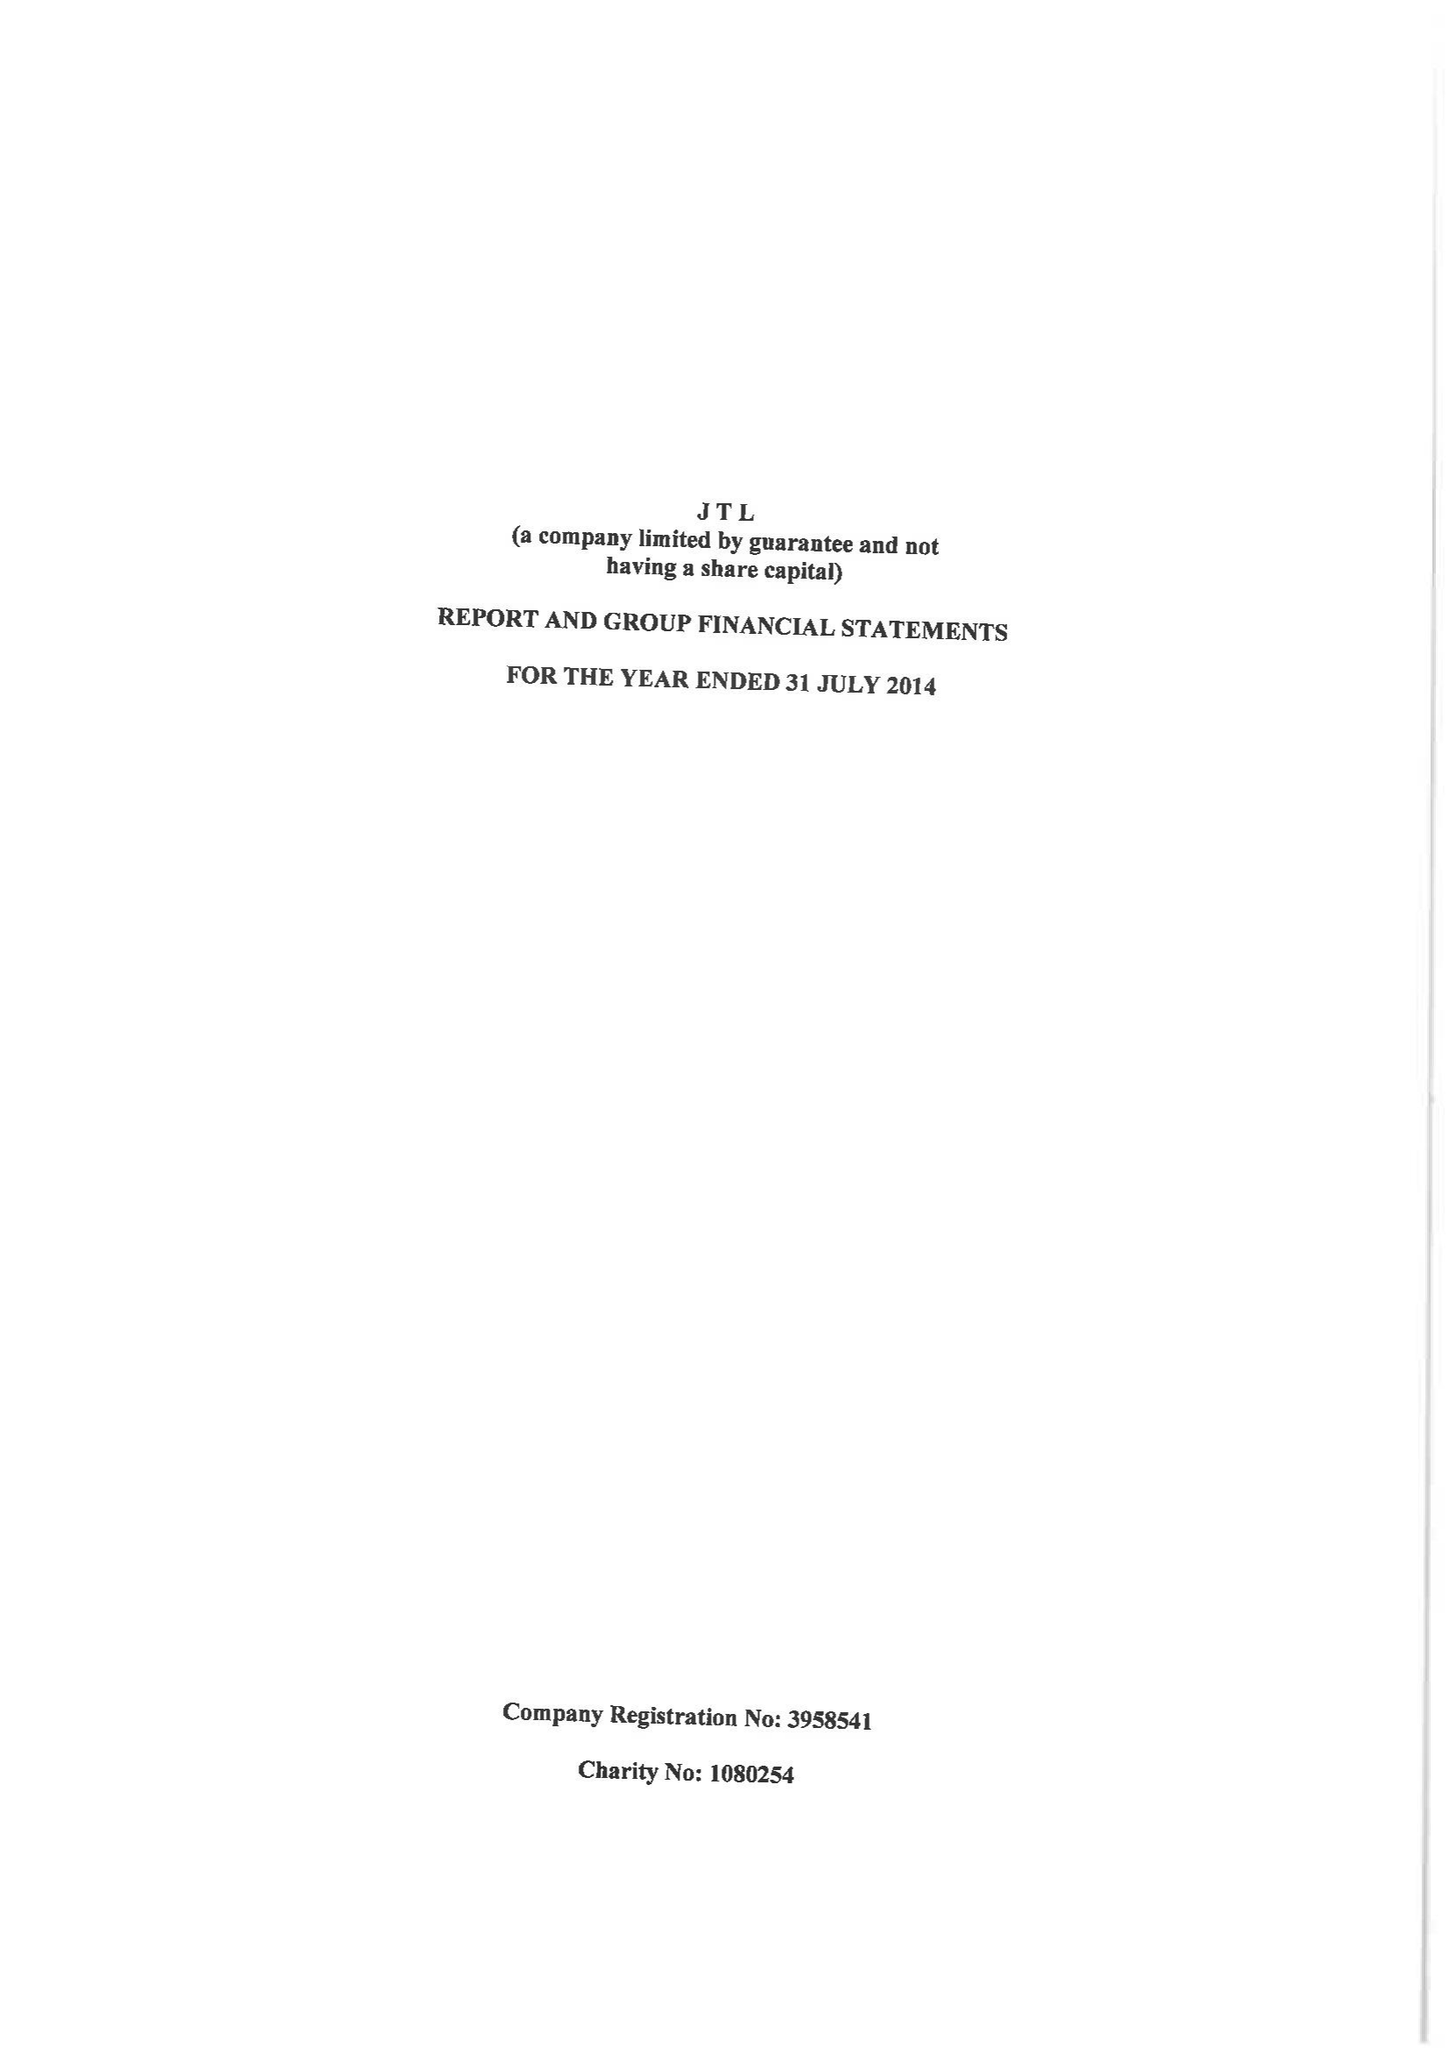What is the value for the address__street_line?
Answer the question using a single word or phrase. 120-122 HIGH STREET 